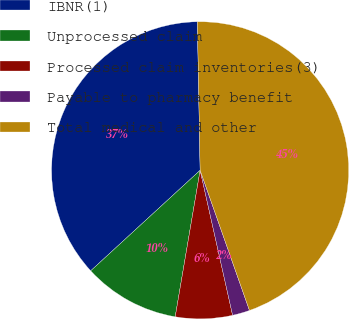Convert chart to OTSL. <chart><loc_0><loc_0><loc_500><loc_500><pie_chart><fcel>IBNR(1)<fcel>Unprocessed claim<fcel>Processed claim inventories(3)<fcel>Payable to pharmacy benefit<fcel>Total medical and other<nl><fcel>36.53%<fcel>10.49%<fcel>6.19%<fcel>1.88%<fcel>44.91%<nl></chart> 